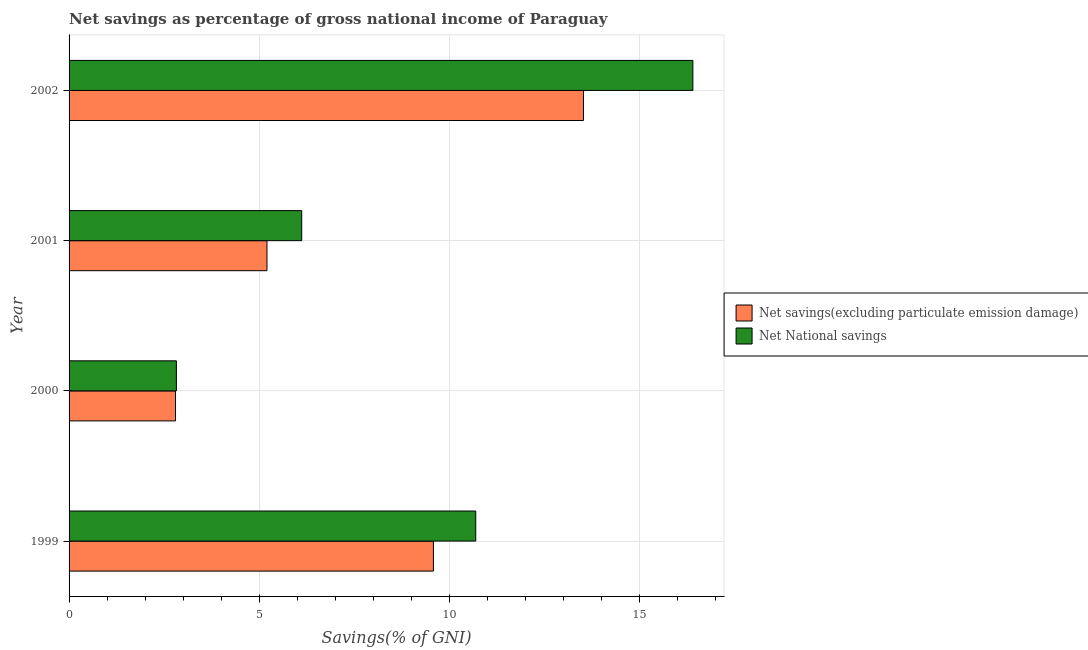How many different coloured bars are there?
Make the answer very short. 2. How many groups of bars are there?
Provide a succinct answer. 4. Are the number of bars per tick equal to the number of legend labels?
Your answer should be compact. Yes. How many bars are there on the 2nd tick from the top?
Ensure brevity in your answer.  2. How many bars are there on the 2nd tick from the bottom?
Make the answer very short. 2. In how many cases, is the number of bars for a given year not equal to the number of legend labels?
Make the answer very short. 0. What is the net national savings in 2001?
Your response must be concise. 6.12. Across all years, what is the maximum net savings(excluding particulate emission damage)?
Your answer should be compact. 13.53. Across all years, what is the minimum net savings(excluding particulate emission damage)?
Provide a short and direct response. 2.8. In which year was the net national savings maximum?
Your answer should be compact. 2002. In which year was the net savings(excluding particulate emission damage) minimum?
Give a very brief answer. 2000. What is the total net national savings in the graph?
Give a very brief answer. 36.06. What is the difference between the net savings(excluding particulate emission damage) in 1999 and that in 2001?
Provide a short and direct response. 4.38. What is the difference between the net national savings in 2000 and the net savings(excluding particulate emission damage) in 2001?
Make the answer very short. -2.38. What is the average net national savings per year?
Offer a very short reply. 9.01. In the year 2001, what is the difference between the net savings(excluding particulate emission damage) and net national savings?
Give a very brief answer. -0.91. In how many years, is the net national savings greater than 13 %?
Ensure brevity in your answer.  1. What is the ratio of the net savings(excluding particulate emission damage) in 2000 to that in 2001?
Your answer should be compact. 0.54. What is the difference between the highest and the second highest net national savings?
Offer a terse response. 5.71. What is the difference between the highest and the lowest net savings(excluding particulate emission damage)?
Offer a very short reply. 10.73. What does the 2nd bar from the top in 1999 represents?
Provide a succinct answer. Net savings(excluding particulate emission damage). What does the 1st bar from the bottom in 2000 represents?
Your answer should be compact. Net savings(excluding particulate emission damage). Where does the legend appear in the graph?
Your response must be concise. Center right. How are the legend labels stacked?
Ensure brevity in your answer.  Vertical. What is the title of the graph?
Provide a succinct answer. Net savings as percentage of gross national income of Paraguay. What is the label or title of the X-axis?
Offer a very short reply. Savings(% of GNI). What is the label or title of the Y-axis?
Offer a terse response. Year. What is the Savings(% of GNI) in Net savings(excluding particulate emission damage) in 1999?
Offer a very short reply. 9.59. What is the Savings(% of GNI) in Net National savings in 1999?
Ensure brevity in your answer.  10.7. What is the Savings(% of GNI) of Net savings(excluding particulate emission damage) in 2000?
Keep it short and to the point. 2.8. What is the Savings(% of GNI) of Net National savings in 2000?
Offer a very short reply. 2.82. What is the Savings(% of GNI) in Net savings(excluding particulate emission damage) in 2001?
Your answer should be compact. 5.21. What is the Savings(% of GNI) in Net National savings in 2001?
Offer a terse response. 6.12. What is the Savings(% of GNI) in Net savings(excluding particulate emission damage) in 2002?
Offer a terse response. 13.53. What is the Savings(% of GNI) in Net National savings in 2002?
Make the answer very short. 16.41. Across all years, what is the maximum Savings(% of GNI) of Net savings(excluding particulate emission damage)?
Offer a very short reply. 13.53. Across all years, what is the maximum Savings(% of GNI) in Net National savings?
Give a very brief answer. 16.41. Across all years, what is the minimum Savings(% of GNI) in Net savings(excluding particulate emission damage)?
Offer a very short reply. 2.8. Across all years, what is the minimum Savings(% of GNI) in Net National savings?
Make the answer very short. 2.82. What is the total Savings(% of GNI) in Net savings(excluding particulate emission damage) in the graph?
Offer a terse response. 31.13. What is the total Savings(% of GNI) of Net National savings in the graph?
Your response must be concise. 36.06. What is the difference between the Savings(% of GNI) in Net savings(excluding particulate emission damage) in 1999 and that in 2000?
Your response must be concise. 6.79. What is the difference between the Savings(% of GNI) in Net National savings in 1999 and that in 2000?
Ensure brevity in your answer.  7.88. What is the difference between the Savings(% of GNI) in Net savings(excluding particulate emission damage) in 1999 and that in 2001?
Offer a very short reply. 4.38. What is the difference between the Savings(% of GNI) in Net National savings in 1999 and that in 2001?
Give a very brief answer. 4.58. What is the difference between the Savings(% of GNI) in Net savings(excluding particulate emission damage) in 1999 and that in 2002?
Give a very brief answer. -3.95. What is the difference between the Savings(% of GNI) of Net National savings in 1999 and that in 2002?
Provide a short and direct response. -5.71. What is the difference between the Savings(% of GNI) of Net savings(excluding particulate emission damage) in 2000 and that in 2001?
Provide a short and direct response. -2.41. What is the difference between the Savings(% of GNI) of Net National savings in 2000 and that in 2001?
Offer a terse response. -3.3. What is the difference between the Savings(% of GNI) of Net savings(excluding particulate emission damage) in 2000 and that in 2002?
Ensure brevity in your answer.  -10.73. What is the difference between the Savings(% of GNI) in Net National savings in 2000 and that in 2002?
Your response must be concise. -13.59. What is the difference between the Savings(% of GNI) in Net savings(excluding particulate emission damage) in 2001 and that in 2002?
Your answer should be compact. -8.33. What is the difference between the Savings(% of GNI) in Net National savings in 2001 and that in 2002?
Provide a succinct answer. -10.29. What is the difference between the Savings(% of GNI) in Net savings(excluding particulate emission damage) in 1999 and the Savings(% of GNI) in Net National savings in 2000?
Give a very brief answer. 6.76. What is the difference between the Savings(% of GNI) in Net savings(excluding particulate emission damage) in 1999 and the Savings(% of GNI) in Net National savings in 2001?
Your response must be concise. 3.46. What is the difference between the Savings(% of GNI) in Net savings(excluding particulate emission damage) in 1999 and the Savings(% of GNI) in Net National savings in 2002?
Make the answer very short. -6.83. What is the difference between the Savings(% of GNI) of Net savings(excluding particulate emission damage) in 2000 and the Savings(% of GNI) of Net National savings in 2001?
Your answer should be compact. -3.32. What is the difference between the Savings(% of GNI) of Net savings(excluding particulate emission damage) in 2000 and the Savings(% of GNI) of Net National savings in 2002?
Offer a very short reply. -13.61. What is the difference between the Savings(% of GNI) in Net savings(excluding particulate emission damage) in 2001 and the Savings(% of GNI) in Net National savings in 2002?
Ensure brevity in your answer.  -11.21. What is the average Savings(% of GNI) in Net savings(excluding particulate emission damage) per year?
Offer a very short reply. 7.78. What is the average Savings(% of GNI) in Net National savings per year?
Keep it short and to the point. 9.01. In the year 1999, what is the difference between the Savings(% of GNI) in Net savings(excluding particulate emission damage) and Savings(% of GNI) in Net National savings?
Your answer should be very brief. -1.11. In the year 2000, what is the difference between the Savings(% of GNI) in Net savings(excluding particulate emission damage) and Savings(% of GNI) in Net National savings?
Provide a short and direct response. -0.02. In the year 2001, what is the difference between the Savings(% of GNI) in Net savings(excluding particulate emission damage) and Savings(% of GNI) in Net National savings?
Offer a very short reply. -0.91. In the year 2002, what is the difference between the Savings(% of GNI) in Net savings(excluding particulate emission damage) and Savings(% of GNI) in Net National savings?
Ensure brevity in your answer.  -2.88. What is the ratio of the Savings(% of GNI) of Net savings(excluding particulate emission damage) in 1999 to that in 2000?
Provide a short and direct response. 3.42. What is the ratio of the Savings(% of GNI) in Net National savings in 1999 to that in 2000?
Your answer should be compact. 3.79. What is the ratio of the Savings(% of GNI) of Net savings(excluding particulate emission damage) in 1999 to that in 2001?
Offer a terse response. 1.84. What is the ratio of the Savings(% of GNI) of Net National savings in 1999 to that in 2001?
Your response must be concise. 1.75. What is the ratio of the Savings(% of GNI) of Net savings(excluding particulate emission damage) in 1999 to that in 2002?
Give a very brief answer. 0.71. What is the ratio of the Savings(% of GNI) in Net National savings in 1999 to that in 2002?
Your answer should be very brief. 0.65. What is the ratio of the Savings(% of GNI) of Net savings(excluding particulate emission damage) in 2000 to that in 2001?
Offer a very short reply. 0.54. What is the ratio of the Savings(% of GNI) in Net National savings in 2000 to that in 2001?
Ensure brevity in your answer.  0.46. What is the ratio of the Savings(% of GNI) in Net savings(excluding particulate emission damage) in 2000 to that in 2002?
Your response must be concise. 0.21. What is the ratio of the Savings(% of GNI) in Net National savings in 2000 to that in 2002?
Your response must be concise. 0.17. What is the ratio of the Savings(% of GNI) of Net savings(excluding particulate emission damage) in 2001 to that in 2002?
Your answer should be compact. 0.38. What is the ratio of the Savings(% of GNI) of Net National savings in 2001 to that in 2002?
Your answer should be compact. 0.37. What is the difference between the highest and the second highest Savings(% of GNI) of Net savings(excluding particulate emission damage)?
Make the answer very short. 3.95. What is the difference between the highest and the second highest Savings(% of GNI) in Net National savings?
Your answer should be compact. 5.71. What is the difference between the highest and the lowest Savings(% of GNI) of Net savings(excluding particulate emission damage)?
Provide a short and direct response. 10.73. What is the difference between the highest and the lowest Savings(% of GNI) in Net National savings?
Ensure brevity in your answer.  13.59. 